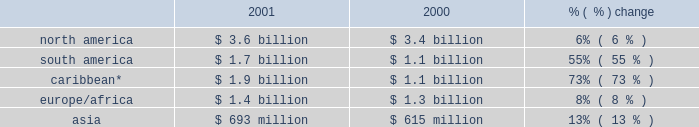Increase .
In north america , contract generation segment revenues increased $ 46 million .
In the caribbean ( which includes venezuela and colombia ) , contract generation segment revenues increased $ 11 million , and this was due to a full year of operations at merida iii offset by a lower capacity factor at los mina .
Competitive supply revenues increased $ 300 million or 13% ( 13 % ) to $ 2.7 billion in 2001 from $ 2.4 billion in 2000 .
Excluding businesses acquired or that commenced commercial operations in 2001 or 2000 , competitive supply revenues increased 3% ( 3 % ) to $ 2.4 billion in 2001 .
The most significant increases occurred within north america and the caribbean .
Slight increases were recorded within south america and asia .
Europe/africa reported a slight decrease due to lower pool prices in the u.k .
Offset by the start of commercial operations at fifoots and the acquisition of ottana .
In north america , competitive supply segment revenues increased $ 184 million due primarily to an expanded customer base at new energy as well as increased operations at placerita .
These increases in north america were offset by lower market prices at our new york businesses .
In the caribbean , competitive supply segment revenues increased $ 123 million due primarily to the acquisition of chivor .
Large utility revenues increased $ 300 million , or 14% ( 14 % ) to $ 2.4 billion in 2001 from $ 2.1 billion in 2000 , principally resulting from the addition of revenues attributable to businesses acquired during 2001 or 2000 .
Excluding businesses acquired in 2001 and 2000 , large utility revenues increased 1% ( 1 % ) to $ 1.6 billion in 2001 .
The majority of the increase occurred within the caribbean , and there was a slight increase in north america .
In the caribbean , revenues increased $ 312 million due to a full year of revenues from edc , which was acquired in june 2000 .
Growth distribution revenues increased $ 400 million , or 31% ( 31 % ) to $ 1.7 billion in 2001 from $ 1.3 billion in 2000 .
Excluding businesses acquired in 2001 or 2000 , growth distribution revenues increased 20% ( 20 % ) to $ 1.3 billion in 2001 .
Revenues increased most significantly in the caribbean and to a lesser extent in south america and europe/africa .
Revenues decreased slightly in asia .
In the caribbean , growth distribution segment revenues increased $ 296 million due primarily to a full year of operations at caess , which was acquired in 2000 and improved operations at ede este .
In south america , growth distribution segment revenues increased $ 89 million due to the significant revenues at sul from our settlement with the brazilian government offset by declines in revenues at our argentine distribution businesses .
The settlement with the brazilian government confirmed the sales price that sul would receive from its sales into the southeast market ( where rationing occurred ) under its itaipu contract .
In europe/africa , growth distribution segment revenues increased $ 59 million from the acquisition of sonel .
In asia , growth distribution segment revenues decreased $ 33 million mainly due to the change in the way in which we are accounting for our investment in cesco .
Cesco was previously consolidated but was changed to equity method during 2001 when the company was removed from management and the board of directors .
This decline was partially offset by the increase in revenues from the distribution businesses that we acquired in the ukraine .
Aes is a global power company which operates in 29 countries around the world .
The breakdown of aes 2019s revenues for the years ended december 31 , 2001 and 2000 , based on the geographic region in which they were earned , is set forth below .
A more detailed breakdown by country can be found in note 16 of the consolidated financial statements. .
* includes venezuela and colombia. .
Was the caribbean segment revenue increase greater than the south american growth ? 
Computations: (296 > 89)
Answer: yes. 